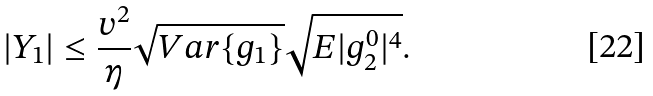<formula> <loc_0><loc_0><loc_500><loc_500>| Y _ { 1 } | \leq { \frac { v ^ { 2 } } { \eta } \sqrt { { V a r } \{ g _ { 1 } \} } \sqrt { { E } | g ^ { 0 } _ { 2 } | ^ { 4 } } } .</formula> 